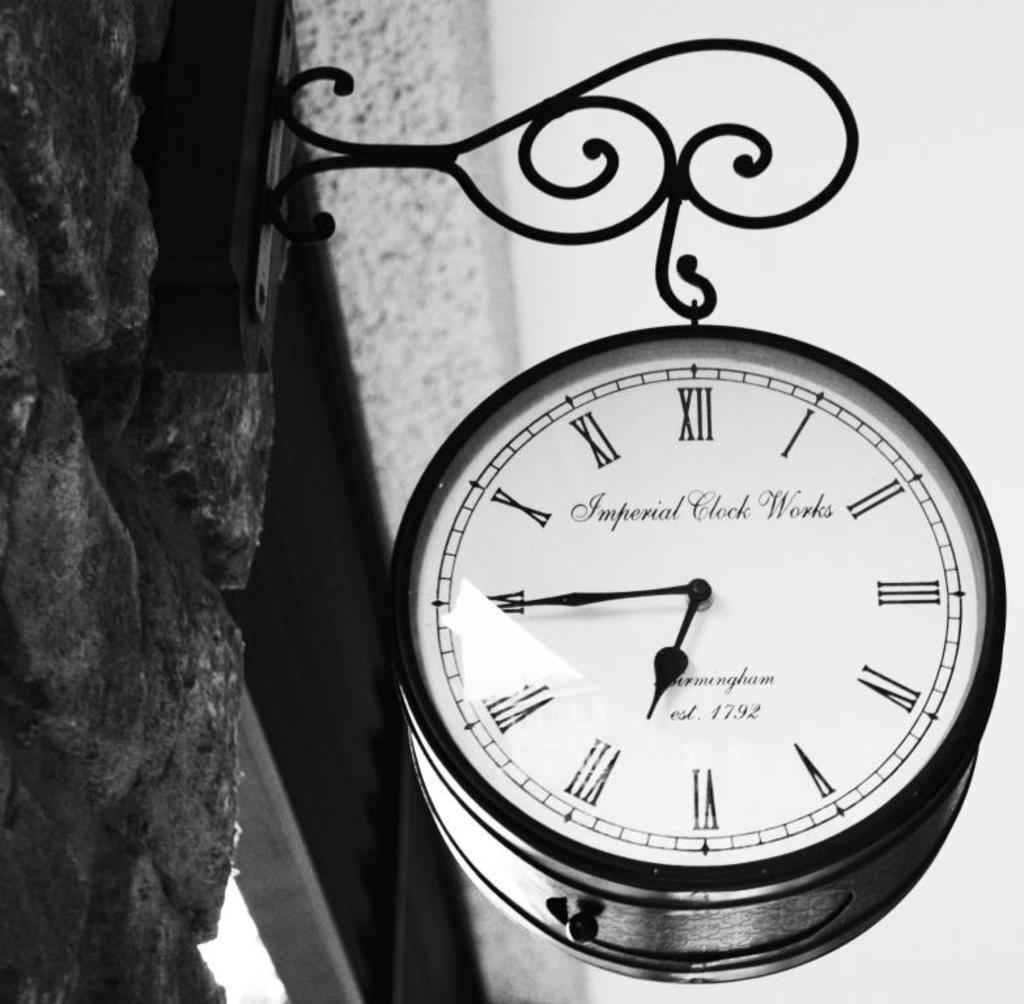<image>
Share a concise interpretation of the image provided. An Imperial Clock Works clock shows that the time is now 6:45. 